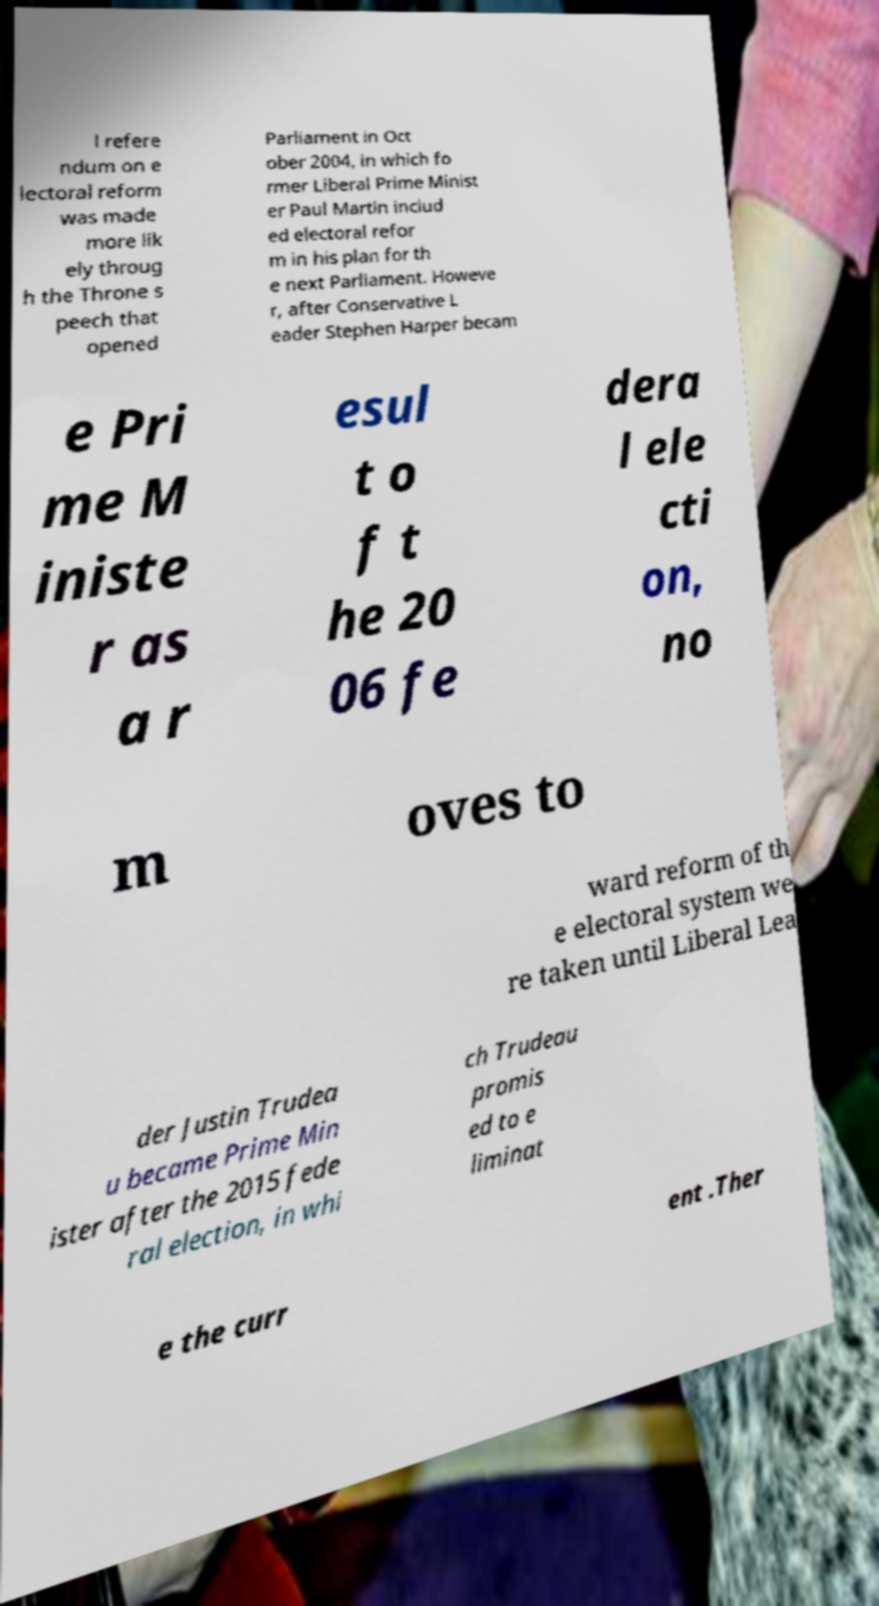What messages or text are displayed in this image? I need them in a readable, typed format. l refere ndum on e lectoral reform was made more lik ely throug h the Throne s peech that opened Parliament in Oct ober 2004, in which fo rmer Liberal Prime Minist er Paul Martin includ ed electoral refor m in his plan for th e next Parliament. Howeve r, after Conservative L eader Stephen Harper becam e Pri me M iniste r as a r esul t o f t he 20 06 fe dera l ele cti on, no m oves to ward reform of th e electoral system we re taken until Liberal Lea der Justin Trudea u became Prime Min ister after the 2015 fede ral election, in whi ch Trudeau promis ed to e liminat e the curr ent .Ther 